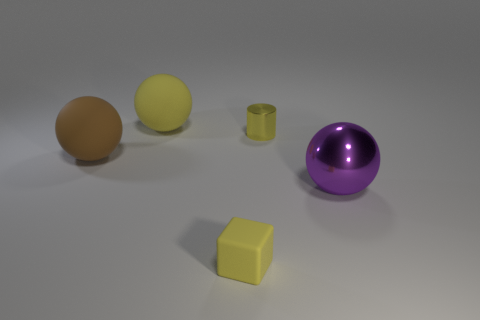There is a metallic thing to the left of the metallic ball; is it the same size as the large purple shiny sphere?
Your answer should be very brief. No. How many objects are either big yellow matte spheres or tiny brown blocks?
Offer a very short reply. 1. There is a big thing right of the metallic thing to the left of the ball that is to the right of the matte cube; what is its material?
Make the answer very short. Metal. There is a big ball that is behind the tiny shiny cylinder; what is it made of?
Offer a very short reply. Rubber. Is there another green cylinder that has the same size as the metal cylinder?
Provide a short and direct response. No. There is a shiny thing that is behind the large metal sphere; does it have the same color as the matte cube?
Your response must be concise. Yes. What number of yellow objects are small shiny cylinders or large metal objects?
Provide a succinct answer. 1. How many large matte objects have the same color as the cylinder?
Your answer should be very brief. 1. Does the large brown object have the same material as the cylinder?
Keep it short and to the point. No. There is a tiny yellow object in front of the large purple shiny object; what number of tiny yellow cubes are in front of it?
Your answer should be very brief. 0. 